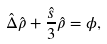Convert formula to latex. <formula><loc_0><loc_0><loc_500><loc_500>\hat { \Delta } \hat { \rho } + \frac { \hat { s } } { 3 } \hat { \rho } = \phi ,</formula> 